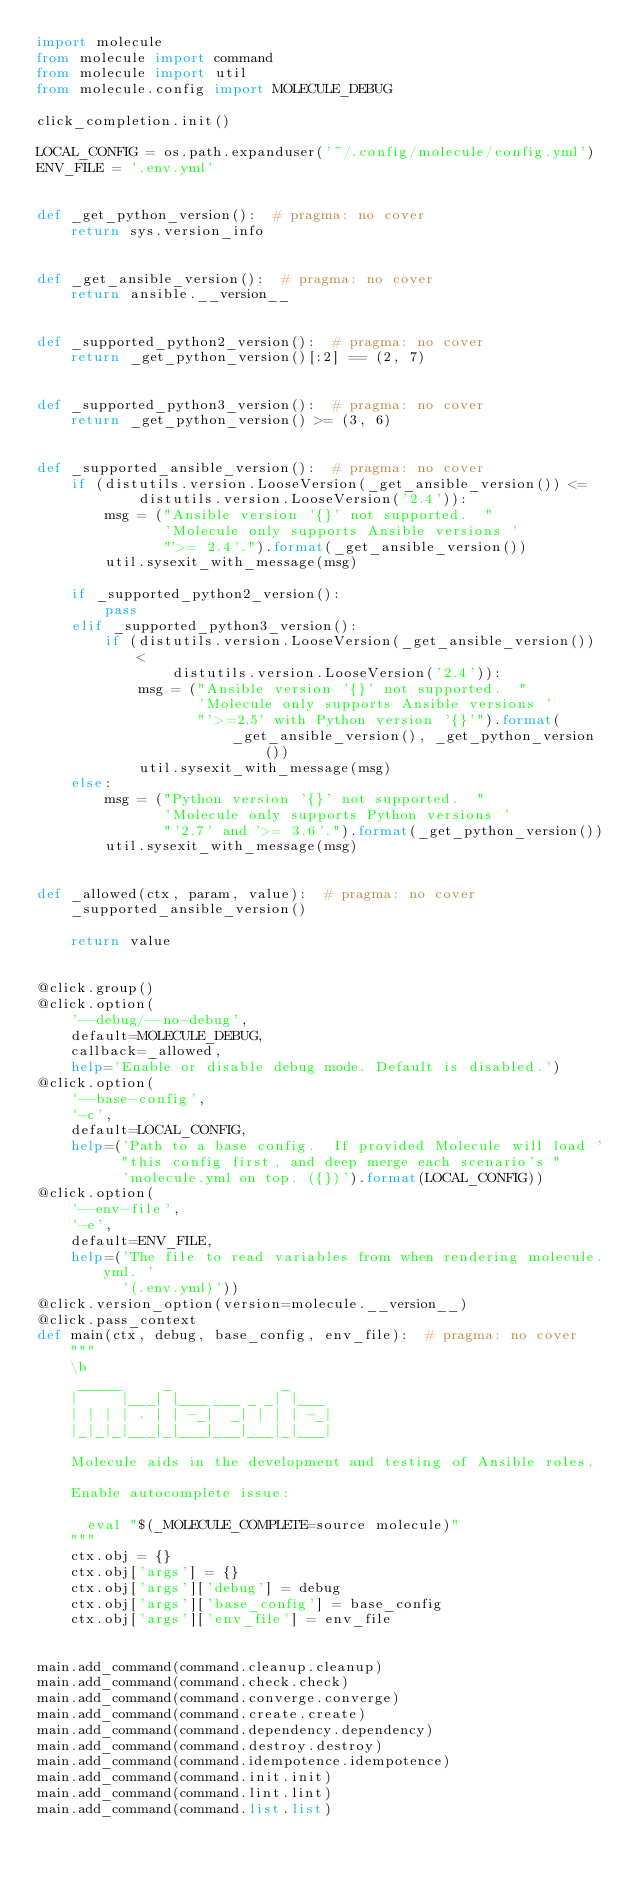Convert code to text. <code><loc_0><loc_0><loc_500><loc_500><_Python_>import molecule
from molecule import command
from molecule import util
from molecule.config import MOLECULE_DEBUG

click_completion.init()

LOCAL_CONFIG = os.path.expanduser('~/.config/molecule/config.yml')
ENV_FILE = '.env.yml'


def _get_python_version():  # pragma: no cover
    return sys.version_info


def _get_ansible_version():  # pragma: no cover
    return ansible.__version__


def _supported_python2_version():  # pragma: no cover
    return _get_python_version()[:2] == (2, 7)


def _supported_python3_version():  # pragma: no cover
    return _get_python_version() >= (3, 6)


def _supported_ansible_version():  # pragma: no cover
    if (distutils.version.LooseVersion(_get_ansible_version()) <=
            distutils.version.LooseVersion('2.4')):
        msg = ("Ansible version '{}' not supported.  "
               'Molecule only supports Ansible versions '
               "'>= 2.4'.").format(_get_ansible_version())
        util.sysexit_with_message(msg)

    if _supported_python2_version():
        pass
    elif _supported_python3_version():
        if (distutils.version.LooseVersion(_get_ansible_version()) <
                distutils.version.LooseVersion('2.4')):
            msg = ("Ansible version '{}' not supported.  "
                   'Molecule only supports Ansible versions '
                   "'>=2.5' with Python version '{}'").format(
                       _get_ansible_version(), _get_python_version())
            util.sysexit_with_message(msg)
    else:
        msg = ("Python version '{}' not supported.  "
               'Molecule only supports Python versions '
               "'2.7' and '>= 3.6'.").format(_get_python_version())
        util.sysexit_with_message(msg)


def _allowed(ctx, param, value):  # pragma: no cover
    _supported_ansible_version()

    return value


@click.group()
@click.option(
    '--debug/--no-debug',
    default=MOLECULE_DEBUG,
    callback=_allowed,
    help='Enable or disable debug mode. Default is disabled.')
@click.option(
    '--base-config',
    '-c',
    default=LOCAL_CONFIG,
    help=('Path to a base config.  If provided Molecule will load '
          "this config first, and deep merge each scenario's "
          'molecule.yml on top. ({})').format(LOCAL_CONFIG))
@click.option(
    '--env-file',
    '-e',
    default=ENV_FILE,
    help=('The file to read variables from when rendering molecule.yml. '
          '(.env.yml)'))
@click.version_option(version=molecule.__version__)
@click.pass_context
def main(ctx, debug, base_config, env_file):  # pragma: no cover
    """
    \b
     _____     _             _
    |     |___| |___ ___ _ _| |___
    | | | | . | | -_|  _| | | | -_|
    |_|_|_|___|_|___|___|___|_|___|

    Molecule aids in the development and testing of Ansible roles.

    Enable autocomplete issue:

      eval "$(_MOLECULE_COMPLETE=source molecule)"
    """
    ctx.obj = {}
    ctx.obj['args'] = {}
    ctx.obj['args']['debug'] = debug
    ctx.obj['args']['base_config'] = base_config
    ctx.obj['args']['env_file'] = env_file


main.add_command(command.cleanup.cleanup)
main.add_command(command.check.check)
main.add_command(command.converge.converge)
main.add_command(command.create.create)
main.add_command(command.dependency.dependency)
main.add_command(command.destroy.destroy)
main.add_command(command.idempotence.idempotence)
main.add_command(command.init.init)
main.add_command(command.lint.lint)
main.add_command(command.list.list)</code> 